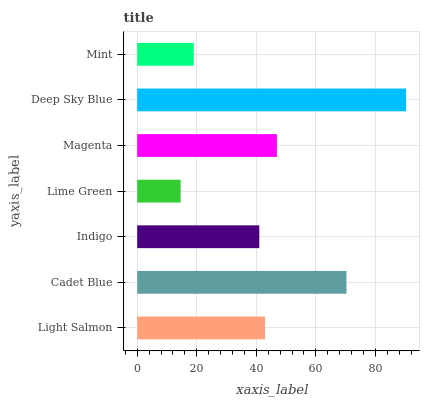Is Lime Green the minimum?
Answer yes or no. Yes. Is Deep Sky Blue the maximum?
Answer yes or no. Yes. Is Cadet Blue the minimum?
Answer yes or no. No. Is Cadet Blue the maximum?
Answer yes or no. No. Is Cadet Blue greater than Light Salmon?
Answer yes or no. Yes. Is Light Salmon less than Cadet Blue?
Answer yes or no. Yes. Is Light Salmon greater than Cadet Blue?
Answer yes or no. No. Is Cadet Blue less than Light Salmon?
Answer yes or no. No. Is Light Salmon the high median?
Answer yes or no. Yes. Is Light Salmon the low median?
Answer yes or no. Yes. Is Cadet Blue the high median?
Answer yes or no. No. Is Mint the low median?
Answer yes or no. No. 